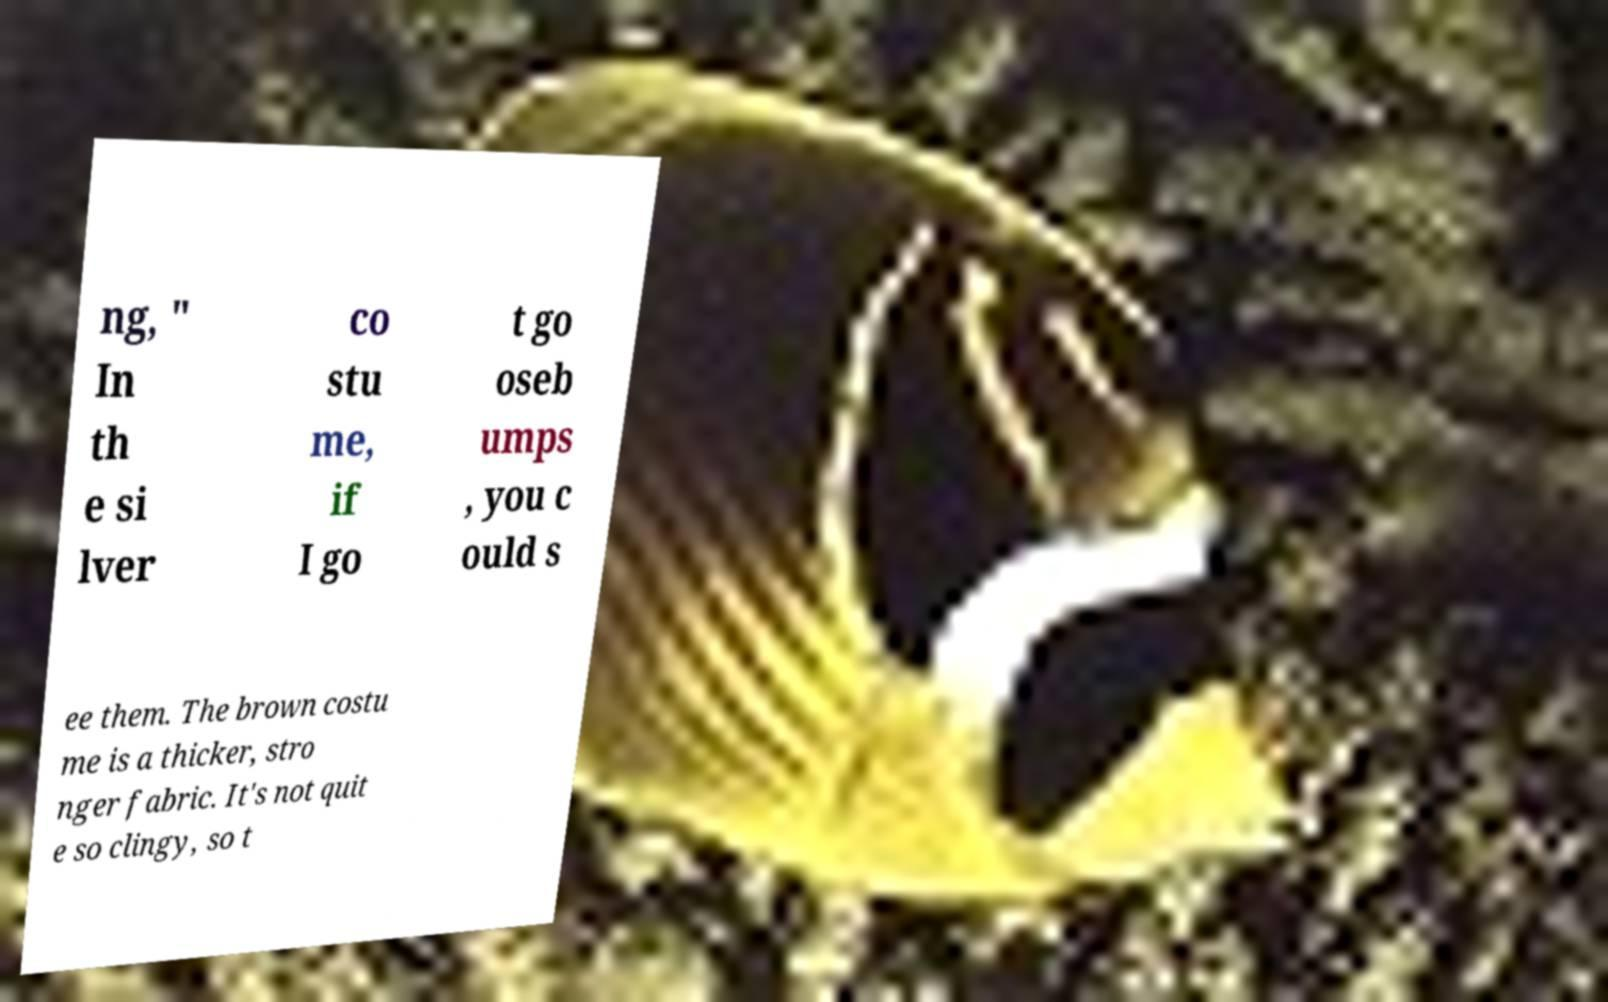Could you assist in decoding the text presented in this image and type it out clearly? ng, " In th e si lver co stu me, if I go t go oseb umps , you c ould s ee them. The brown costu me is a thicker, stro nger fabric. It's not quit e so clingy, so t 